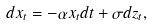Convert formula to latex. <formula><loc_0><loc_0><loc_500><loc_500>d x _ { t } = - \alpha x _ { t } d t + \sigma d z _ { t } ,</formula> 